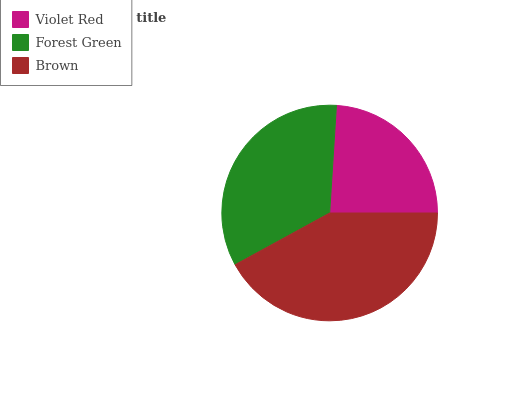Is Violet Red the minimum?
Answer yes or no. Yes. Is Brown the maximum?
Answer yes or no. Yes. Is Forest Green the minimum?
Answer yes or no. No. Is Forest Green the maximum?
Answer yes or no. No. Is Forest Green greater than Violet Red?
Answer yes or no. Yes. Is Violet Red less than Forest Green?
Answer yes or no. Yes. Is Violet Red greater than Forest Green?
Answer yes or no. No. Is Forest Green less than Violet Red?
Answer yes or no. No. Is Forest Green the high median?
Answer yes or no. Yes. Is Forest Green the low median?
Answer yes or no. Yes. Is Brown the high median?
Answer yes or no. No. Is Brown the low median?
Answer yes or no. No. 